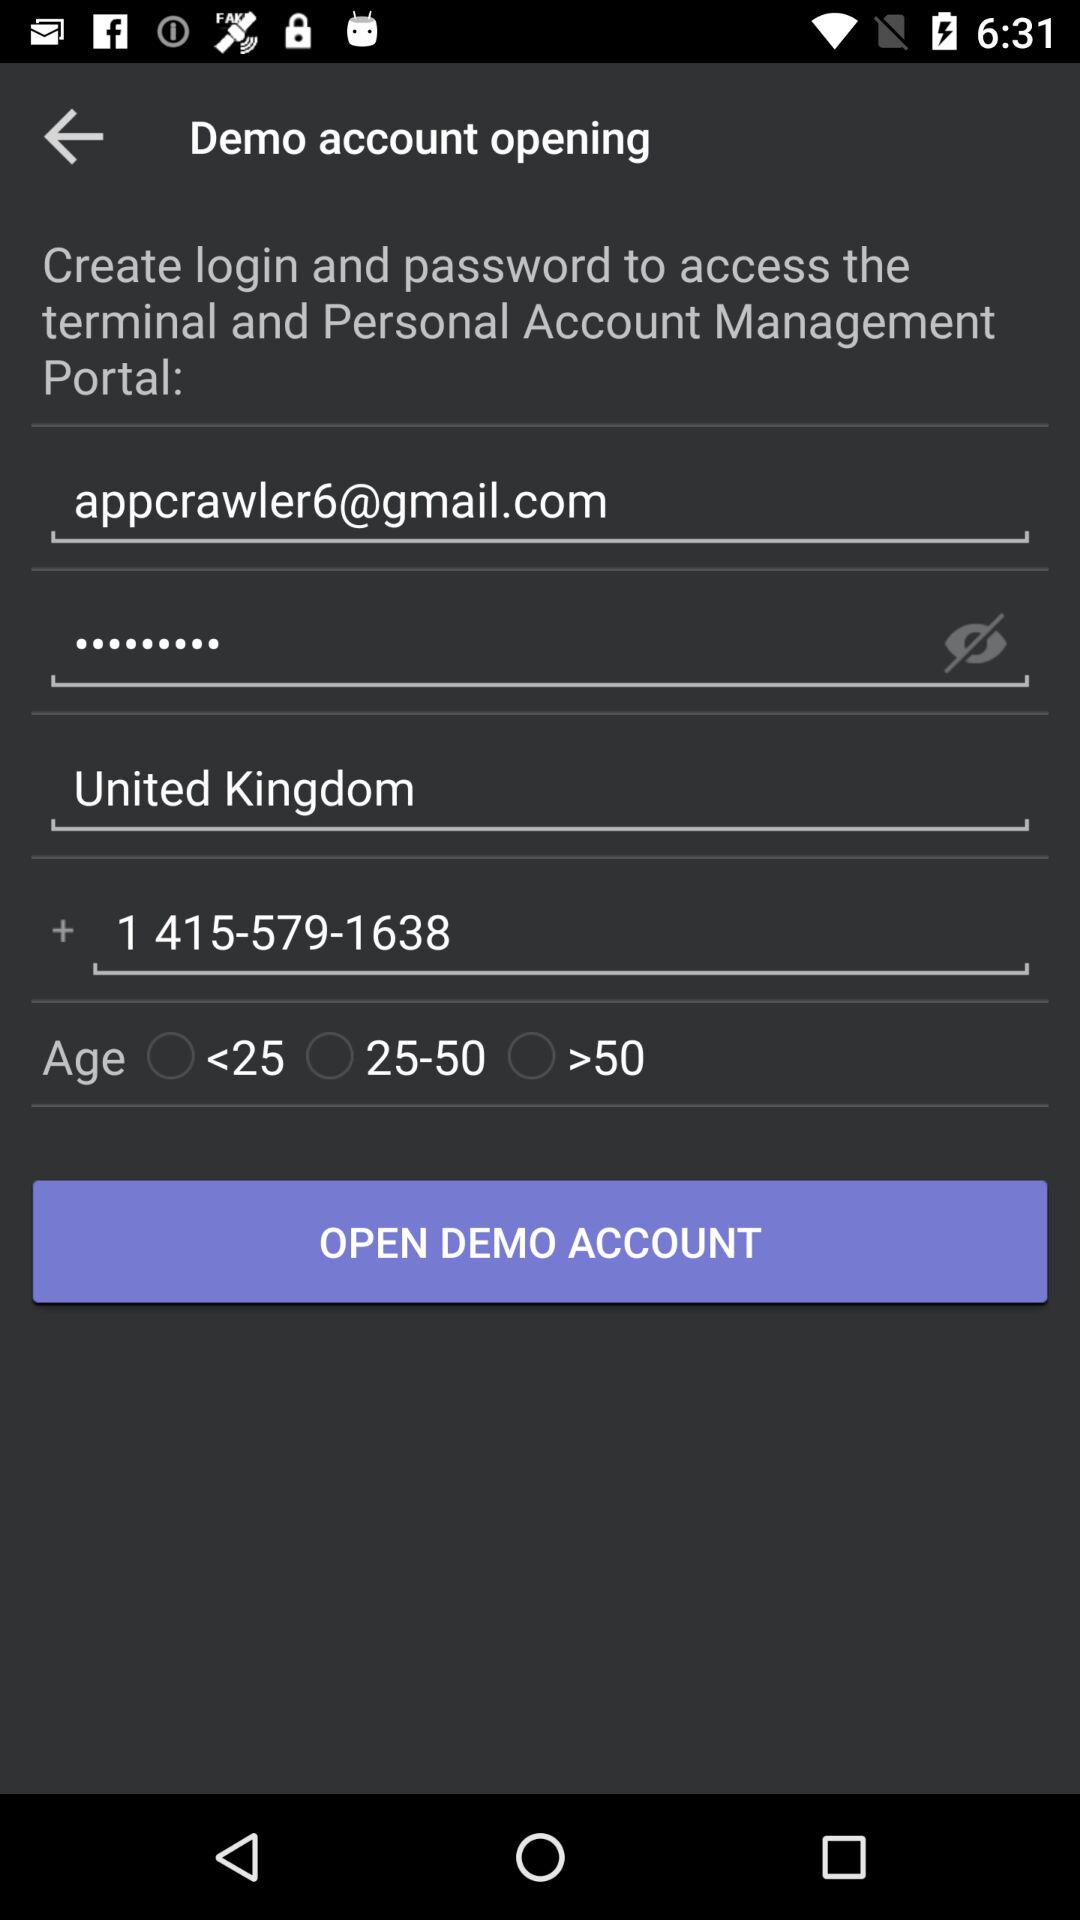What is the name of the place? The name of the place is the United Kingdom. 